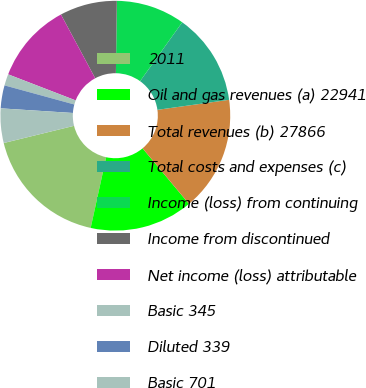Convert chart to OTSL. <chart><loc_0><loc_0><loc_500><loc_500><pie_chart><fcel>2011<fcel>Oil and gas revenues (a) 22941<fcel>Total revenues (b) 27866<fcel>Total costs and expenses (c)<fcel>Income (loss) from continuing<fcel>Income from discontinued<fcel>Net income (loss) attributable<fcel>Basic 345<fcel>Diluted 339<fcel>Basic 701<nl><fcel>17.74%<fcel>14.52%<fcel>16.13%<fcel>12.9%<fcel>9.68%<fcel>8.06%<fcel>11.29%<fcel>1.61%<fcel>3.23%<fcel>4.84%<nl></chart> 